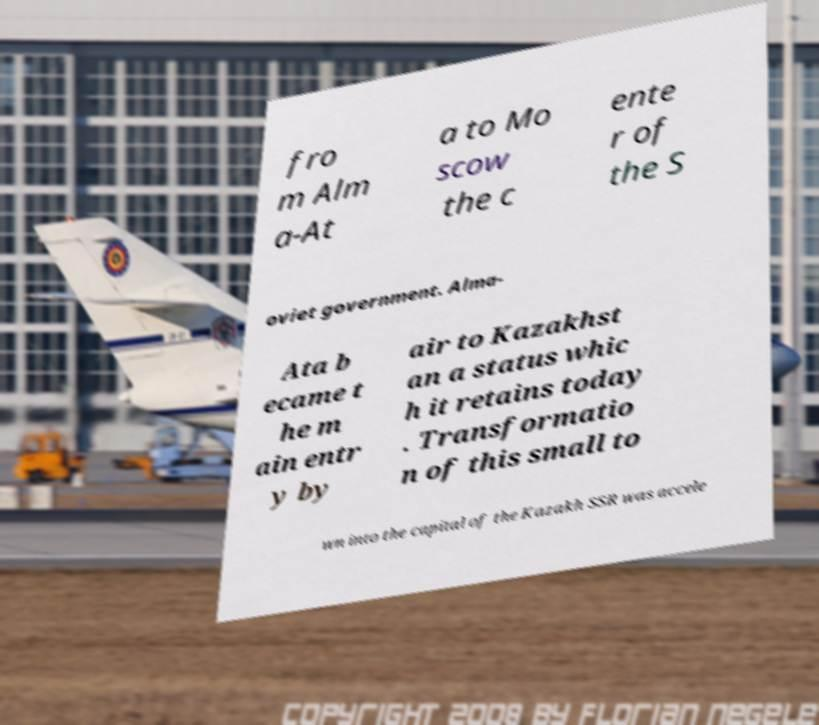Please read and relay the text visible in this image. What does it say? fro m Alm a-At a to Mo scow the c ente r of the S oviet government. Alma- Ata b ecame t he m ain entr y by air to Kazakhst an a status whic h it retains today . Transformatio n of this small to wn into the capital of the Kazakh SSR was accele 